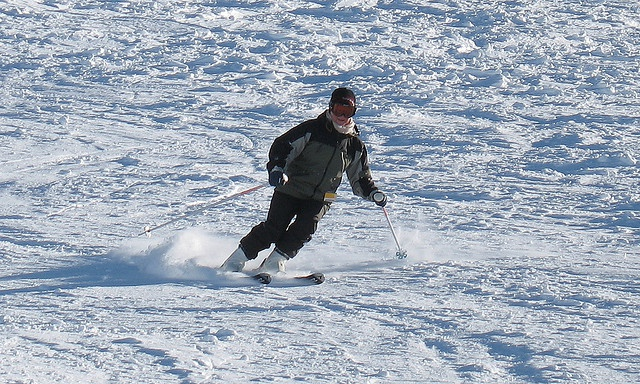Describe the objects in this image and their specific colors. I can see people in gray, black, darkgray, and lightgray tones and skis in gray and black tones in this image. 